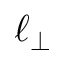Convert formula to latex. <formula><loc_0><loc_0><loc_500><loc_500>\ell _ { \perp }</formula> 